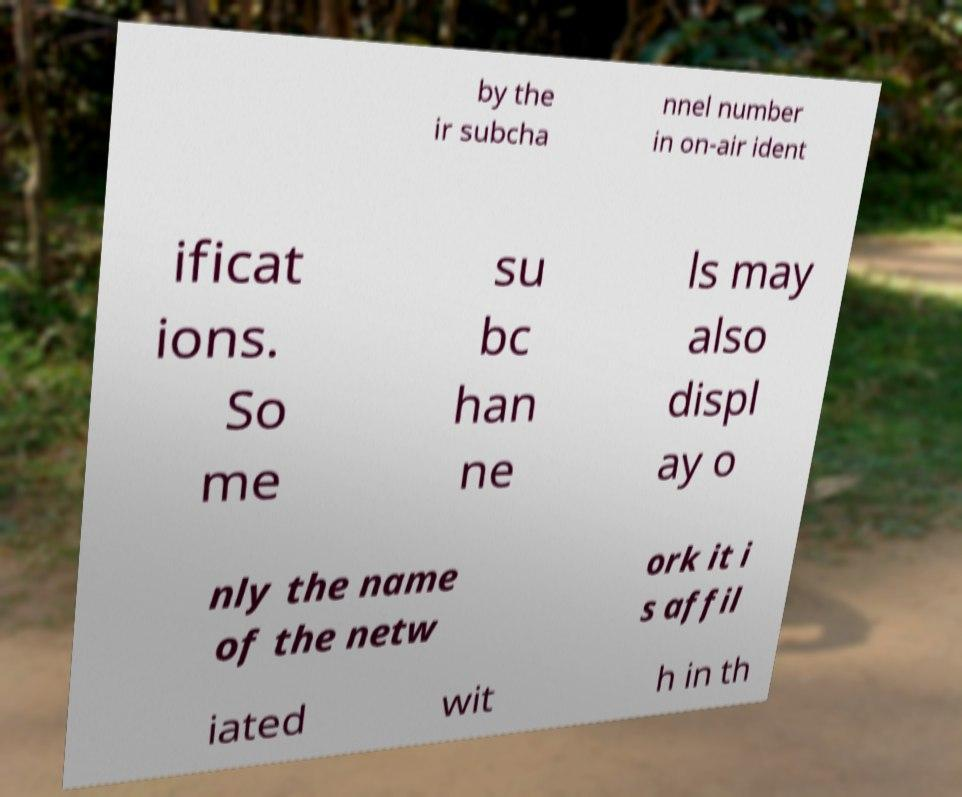I need the written content from this picture converted into text. Can you do that? by the ir subcha nnel number in on-air ident ificat ions. So me su bc han ne ls may also displ ay o nly the name of the netw ork it i s affil iated wit h in th 